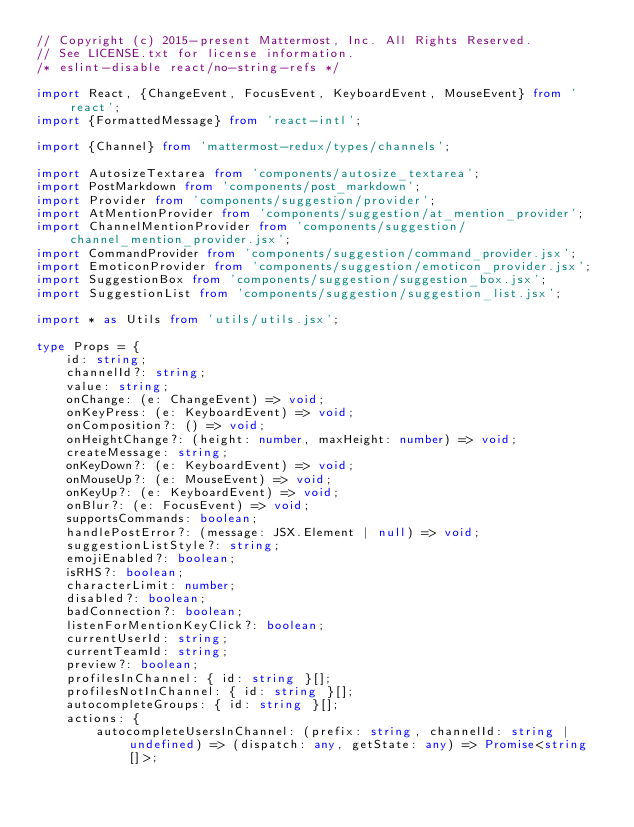<code> <loc_0><loc_0><loc_500><loc_500><_TypeScript_>// Copyright (c) 2015-present Mattermost, Inc. All Rights Reserved.
// See LICENSE.txt for license information.
/* eslint-disable react/no-string-refs */

import React, {ChangeEvent, FocusEvent, KeyboardEvent, MouseEvent} from 'react';
import {FormattedMessage} from 'react-intl';

import {Channel} from 'mattermost-redux/types/channels';

import AutosizeTextarea from 'components/autosize_textarea';
import PostMarkdown from 'components/post_markdown';
import Provider from 'components/suggestion/provider';
import AtMentionProvider from 'components/suggestion/at_mention_provider';
import ChannelMentionProvider from 'components/suggestion/channel_mention_provider.jsx';
import CommandProvider from 'components/suggestion/command_provider.jsx';
import EmoticonProvider from 'components/suggestion/emoticon_provider.jsx';
import SuggestionBox from 'components/suggestion/suggestion_box.jsx';
import SuggestionList from 'components/suggestion/suggestion_list.jsx';

import * as Utils from 'utils/utils.jsx';

type Props = {
    id: string;
    channelId?: string;
    value: string;
    onChange: (e: ChangeEvent) => void;
    onKeyPress: (e: KeyboardEvent) => void;
    onComposition?: () => void;
    onHeightChange?: (height: number, maxHeight: number) => void;
    createMessage: string;
    onKeyDown?: (e: KeyboardEvent) => void;
    onMouseUp?: (e: MouseEvent) => void;
    onKeyUp?: (e: KeyboardEvent) => void;
    onBlur?: (e: FocusEvent) => void;
    supportsCommands: boolean;
    handlePostError?: (message: JSX.Element | null) => void;
    suggestionListStyle?: string;
    emojiEnabled?: boolean;
    isRHS?: boolean;
    characterLimit: number;
    disabled?: boolean;
    badConnection?: boolean;
    listenForMentionKeyClick?: boolean;
    currentUserId: string;
    currentTeamId: string;
    preview?: boolean;
    profilesInChannel: { id: string }[];
    profilesNotInChannel: { id: string }[];
    autocompleteGroups: { id: string }[];
    actions: {
        autocompleteUsersInChannel: (prefix: string, channelId: string | undefined) => (dispatch: any, getState: any) => Promise<string[]>;</code> 